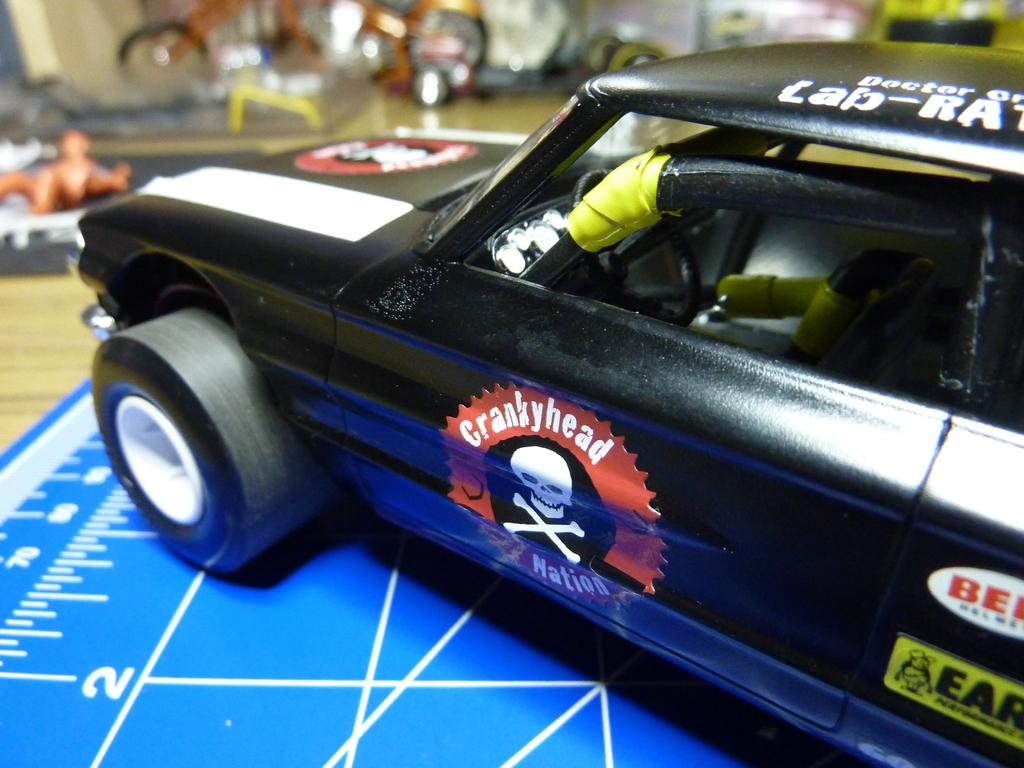What type of toy is in the image? There is a toy car in the image. What color is the toy car? The toy car is black in color. What can be seen beneath the toy car in the image? There is a blue floor visible in the image. What type of skin is visible on the toy car in the image? There is no skin visible on the toy car in the image, as it is a toy and not a living organism. 